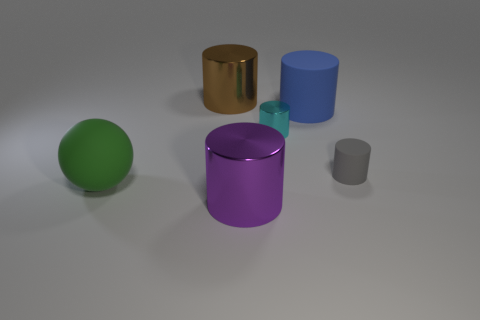Are there any other things that have the same shape as the big green object?
Offer a very short reply. No. How many purple things are there?
Your response must be concise. 1. Do the ball and the tiny metal object have the same color?
Provide a short and direct response. No. Is the number of large rubber cylinders that are to the left of the large rubber cylinder less than the number of cyan metal objects that are behind the tiny gray cylinder?
Give a very brief answer. Yes. What color is the large ball?
Keep it short and to the point. Green. What number of rubber things have the same color as the tiny rubber cylinder?
Your answer should be compact. 0. Are there any blue matte cylinders left of the tiny cyan cylinder?
Offer a very short reply. No. Is the number of small cyan things on the left side of the big blue rubber thing the same as the number of large metal objects right of the tiny gray rubber cylinder?
Offer a terse response. No. Does the blue thing that is right of the large brown object have the same size as the rubber cylinder that is in front of the tiny metallic object?
Give a very brief answer. No. What shape is the big matte object on the left side of the large matte thing behind the thing on the left side of the large brown cylinder?
Provide a short and direct response. Sphere. 